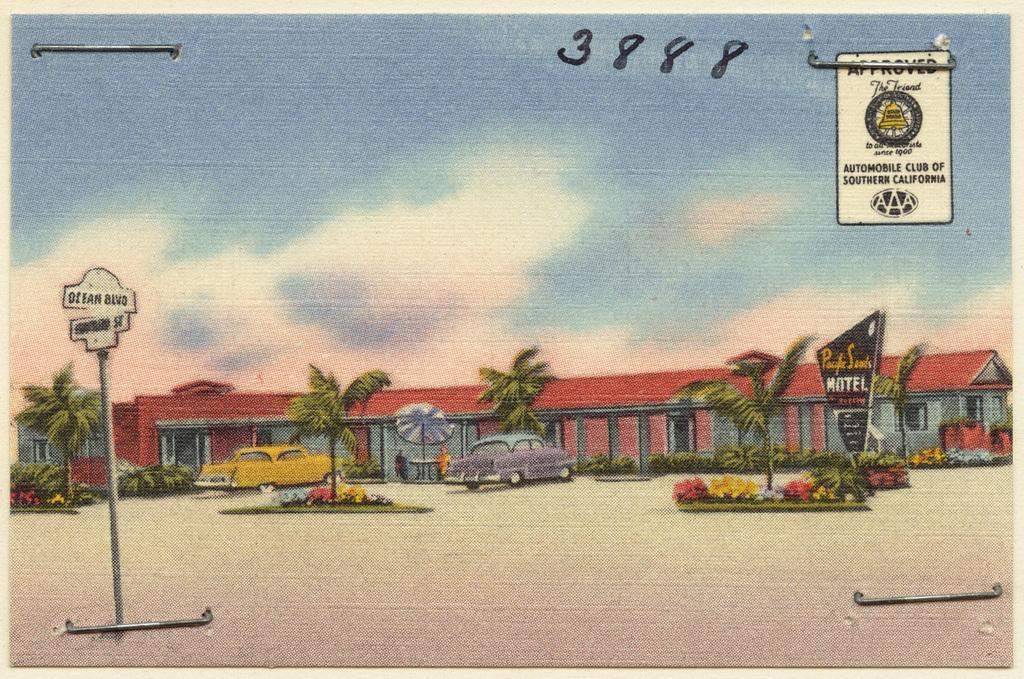What is the main subject of the image? The image contains a painting. What elements are depicted in the painting? The painting depicts buildings, cars, flowers, trees, and a sign board. What part of the natural environment is visible in the painting? The sky is visible in the painting. How many geese are depicted in the painting? There are no geese depicted in the painting; it features buildings, cars, flowers, trees, and a sign board. What type of egg can be seen in the painting? There are no eggs present in the painting; it depicts buildings, cars, flowers, trees, and a sign board. 